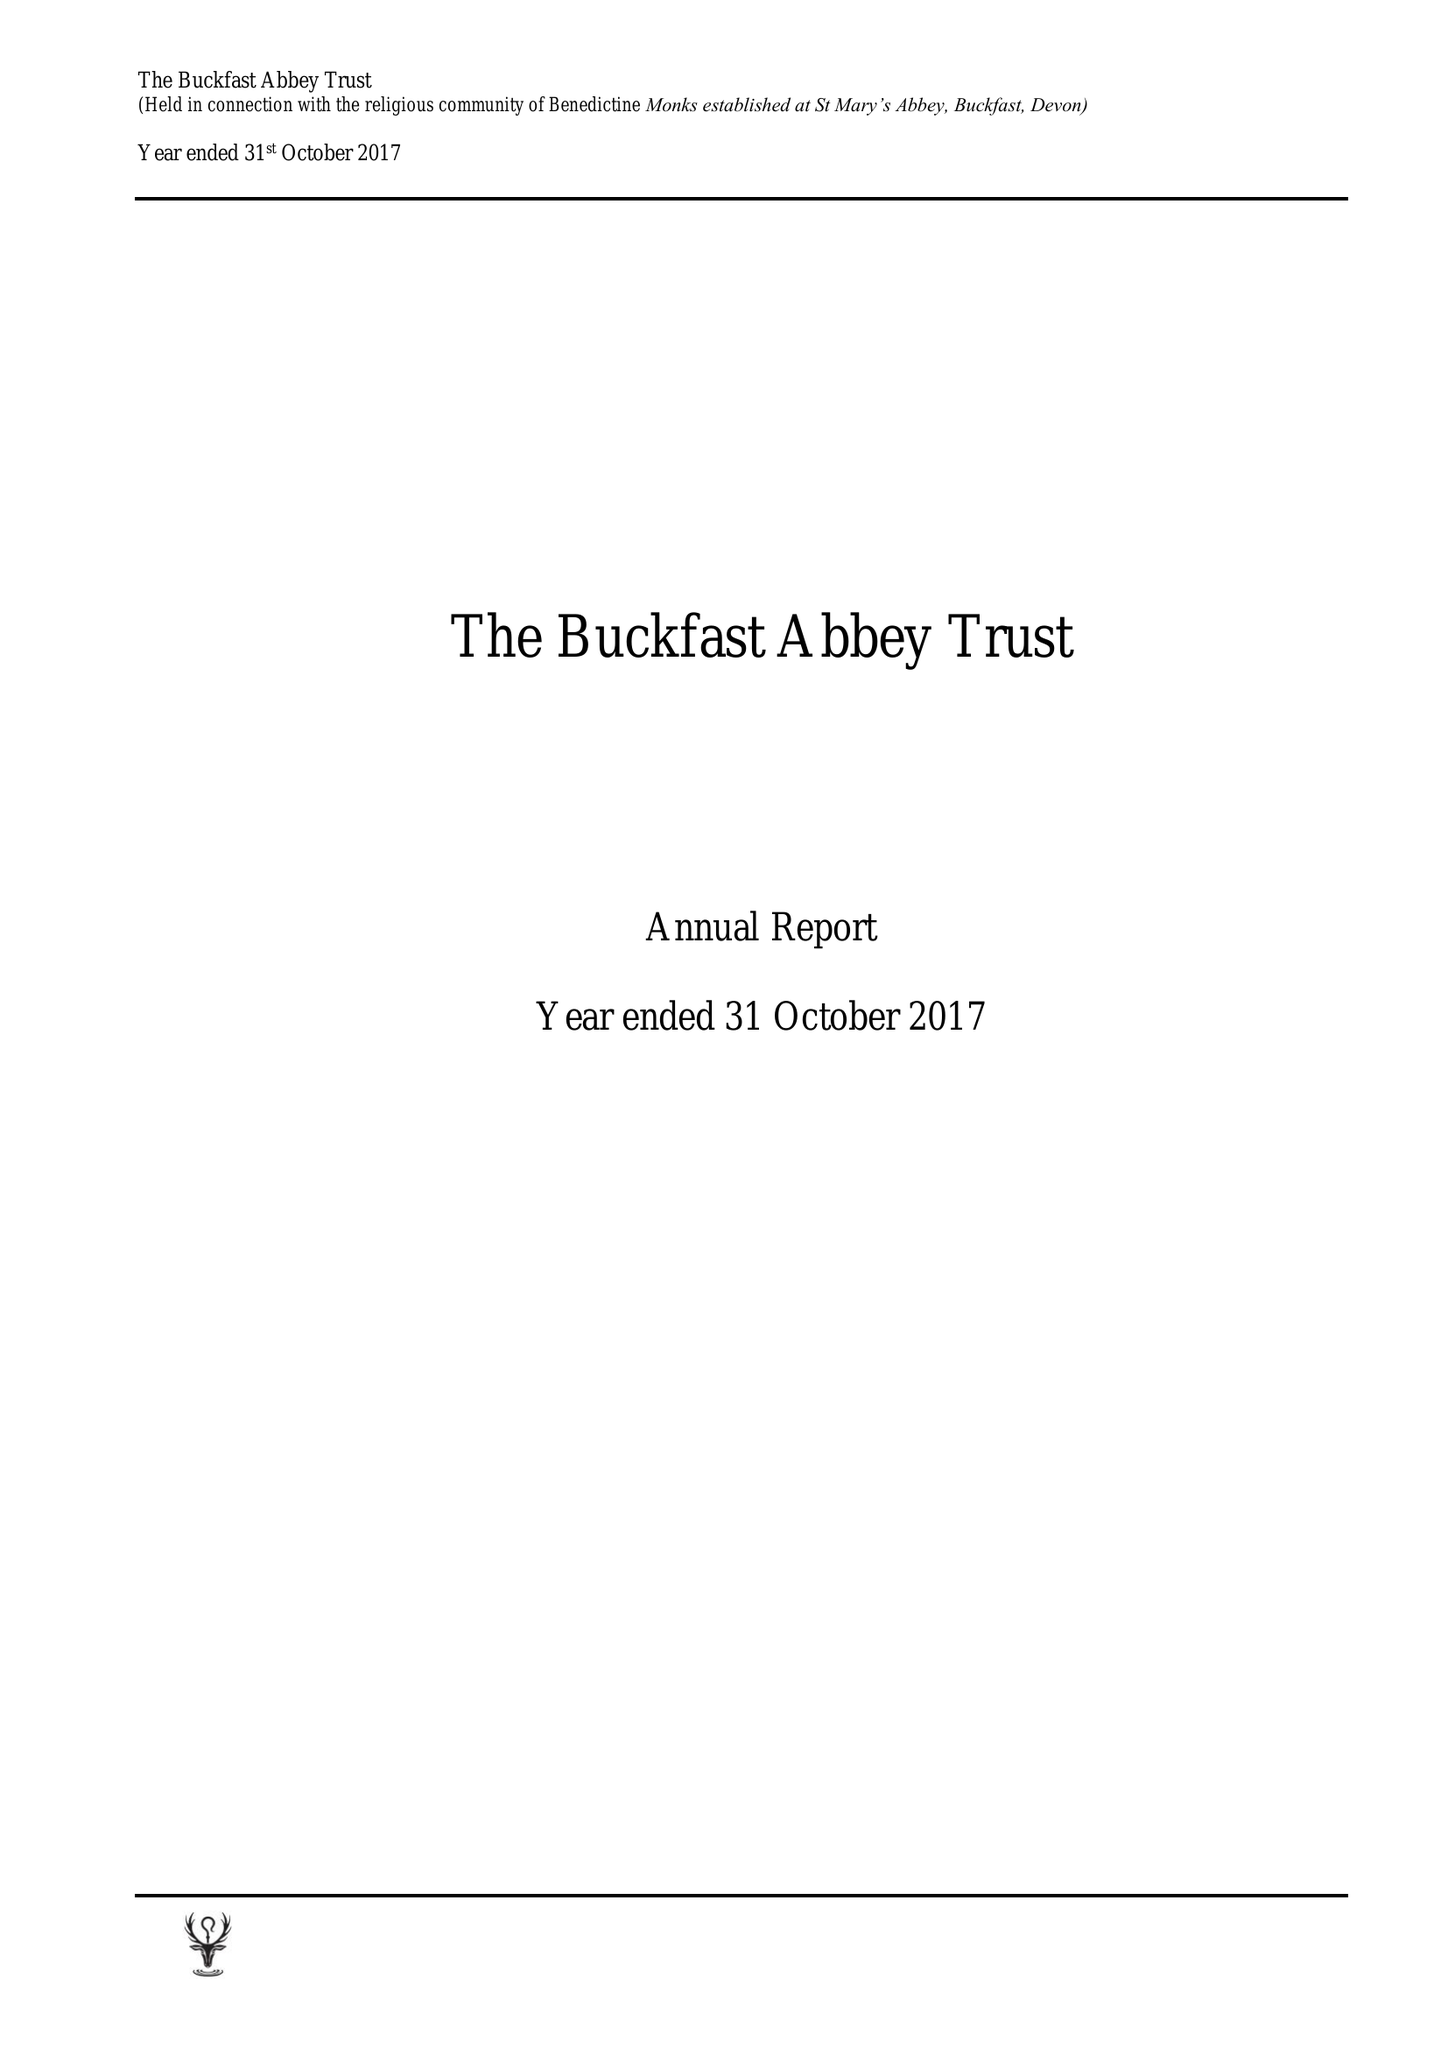What is the value for the charity_number?
Answer the question using a single word or phrase. 232497 